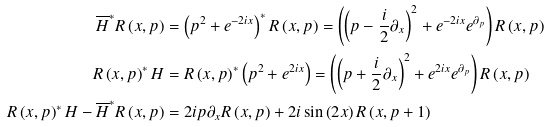<formula> <loc_0><loc_0><loc_500><loc_500>\overline { H } ^ { * } R \left ( x , p \right ) & = \left ( p ^ { 2 } + e ^ { - 2 i x } \right ) ^ { * } R \left ( x , p \right ) = \left ( \left ( p - \frac { i } { 2 } \partial _ { x } \right ) ^ { 2 } + e ^ { - 2 i x } e ^ { \partial _ { p } } \right ) R \left ( x , p \right ) \\ R \left ( x , p \right ) ^ { * } H & = R \left ( x , p \right ) ^ { * } \left ( p ^ { 2 } + e ^ { 2 i x } \right ) = \left ( \left ( p + \frac { i } { 2 } \partial _ { x } \right ) ^ { 2 } + e ^ { 2 i x } e ^ { \partial _ { p } } \right ) R \left ( x , p \right ) \\ R \left ( x , p \right ) ^ { * } H - \overline { H } ^ { * } R \left ( x , p \right ) & = 2 i p \partial _ { x } R \left ( x , p \right ) + 2 i \sin \left ( 2 x \right ) R \left ( x , p + 1 \right )</formula> 